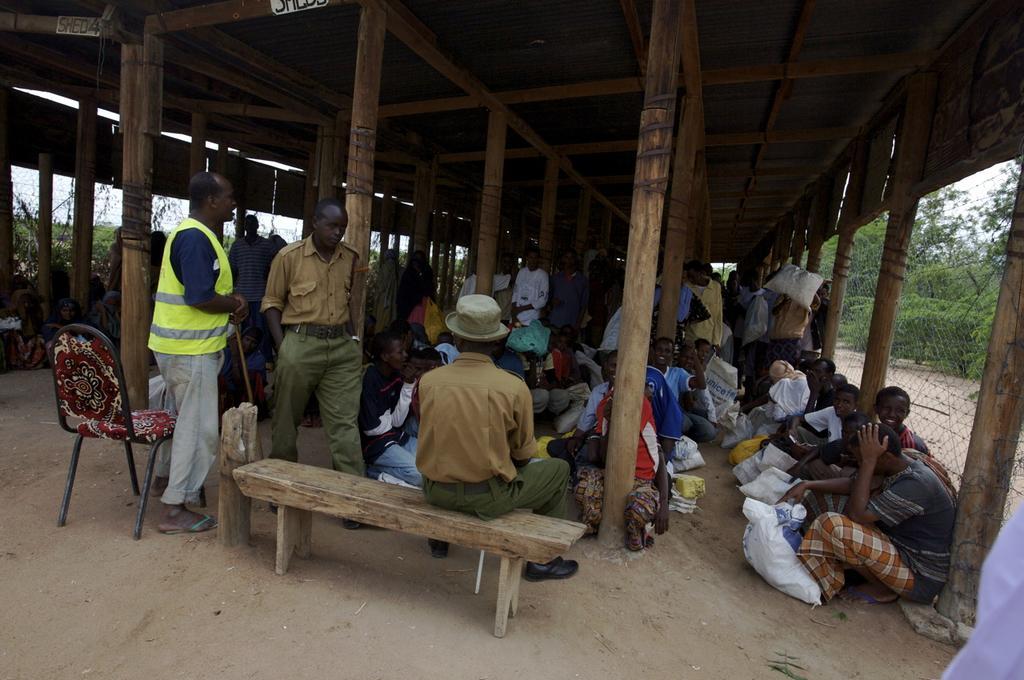In one or two sentences, can you explain what this image depicts? there are many people in this image, few are sitting and few are standing. a person at the front is sitting on the bench. next to him there is a chair. at the most right and left there is a fencing and behind that there are trees. 